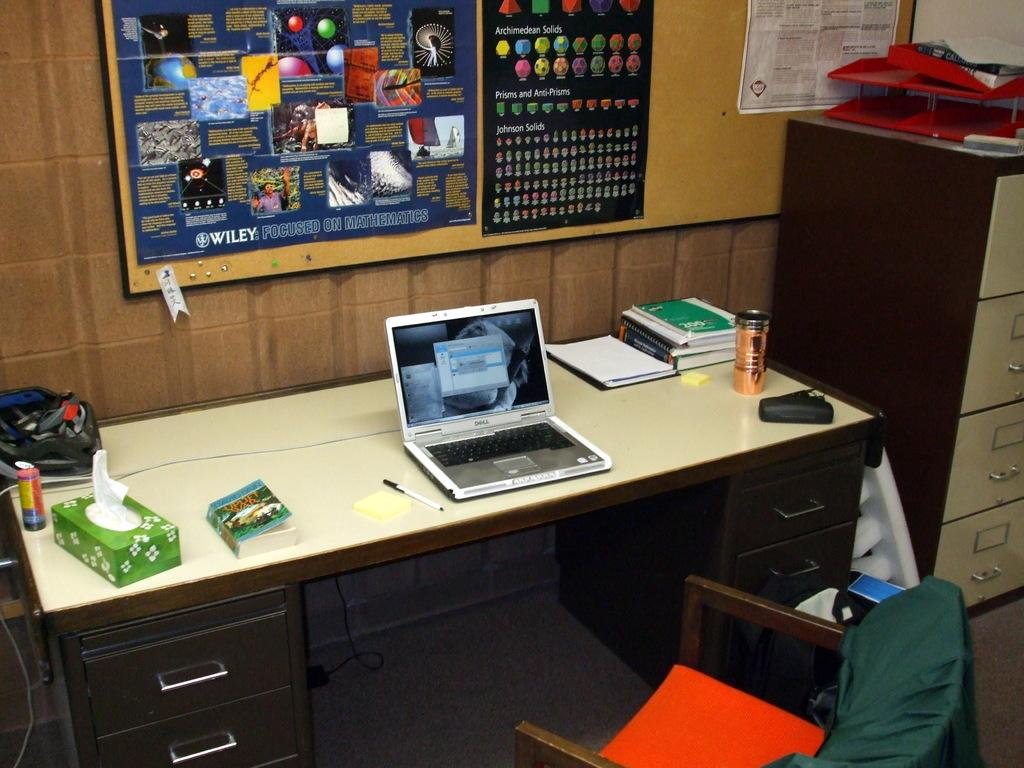<image>
Share a concise interpretation of the image provided. an open laptop on a desk in front of a post which has the words 'Johnson solids' on it 